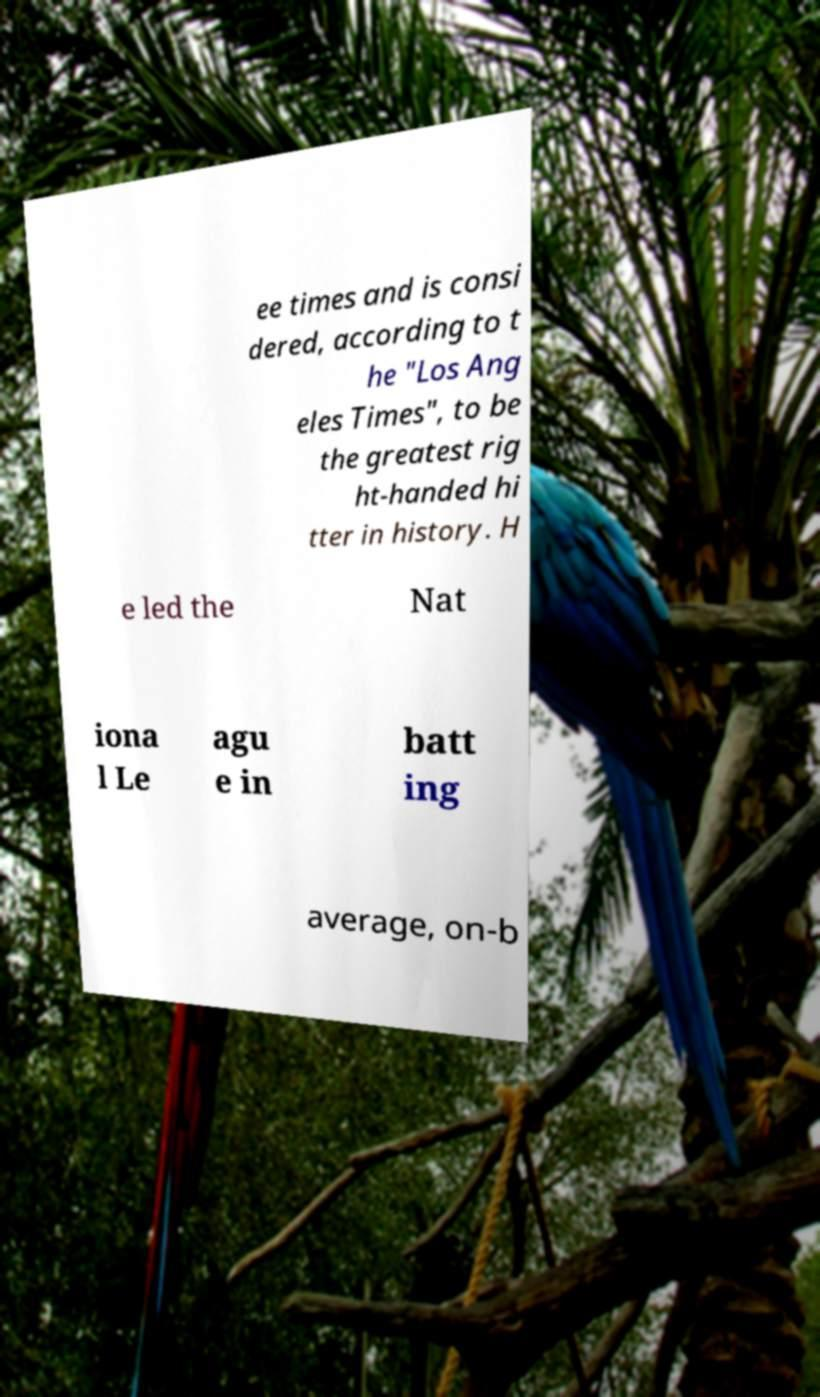Please identify and transcribe the text found in this image. ee times and is consi dered, according to t he "Los Ang eles Times", to be the greatest rig ht-handed hi tter in history. H e led the Nat iona l Le agu e in batt ing average, on-b 